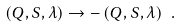Convert formula to latex. <formula><loc_0><loc_0><loc_500><loc_500>\left ( Q , S , \lambda \right ) \rightarrow - \left ( Q , S , \lambda \right ) \ .</formula> 